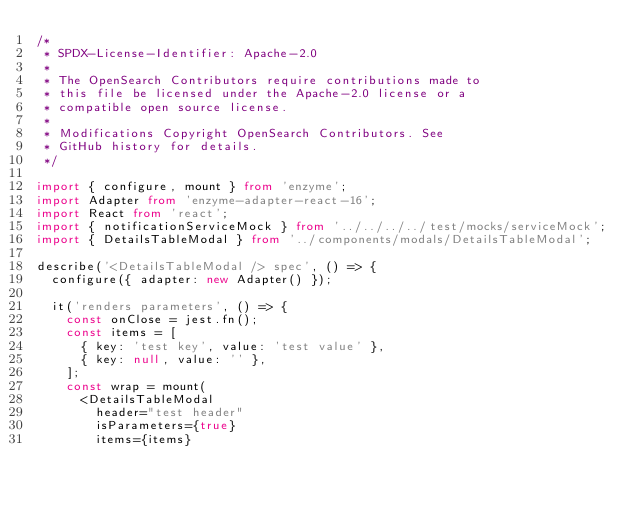Convert code to text. <code><loc_0><loc_0><loc_500><loc_500><_TypeScript_>/*
 * SPDX-License-Identifier: Apache-2.0
 *
 * The OpenSearch Contributors require contributions made to
 * this file be licensed under the Apache-2.0 license or a
 * compatible open source license.
 *
 * Modifications Copyright OpenSearch Contributors. See
 * GitHub history for details.
 */

import { configure, mount } from 'enzyme';
import Adapter from 'enzyme-adapter-react-16';
import React from 'react';
import { notificationServiceMock } from '../../../../test/mocks/serviceMock';
import { DetailsTableModal } from '../components/modals/DetailsTableModal';

describe('<DetailsTableModal /> spec', () => {
  configure({ adapter: new Adapter() });

  it('renders parameters', () => {
    const onClose = jest.fn();
    const items = [
      { key: 'test key', value: 'test value' },
      { key: null, value: '' },
    ];
    const wrap = mount(
      <DetailsTableModal
        header="test header"
        isParameters={true}
        items={items}</code> 